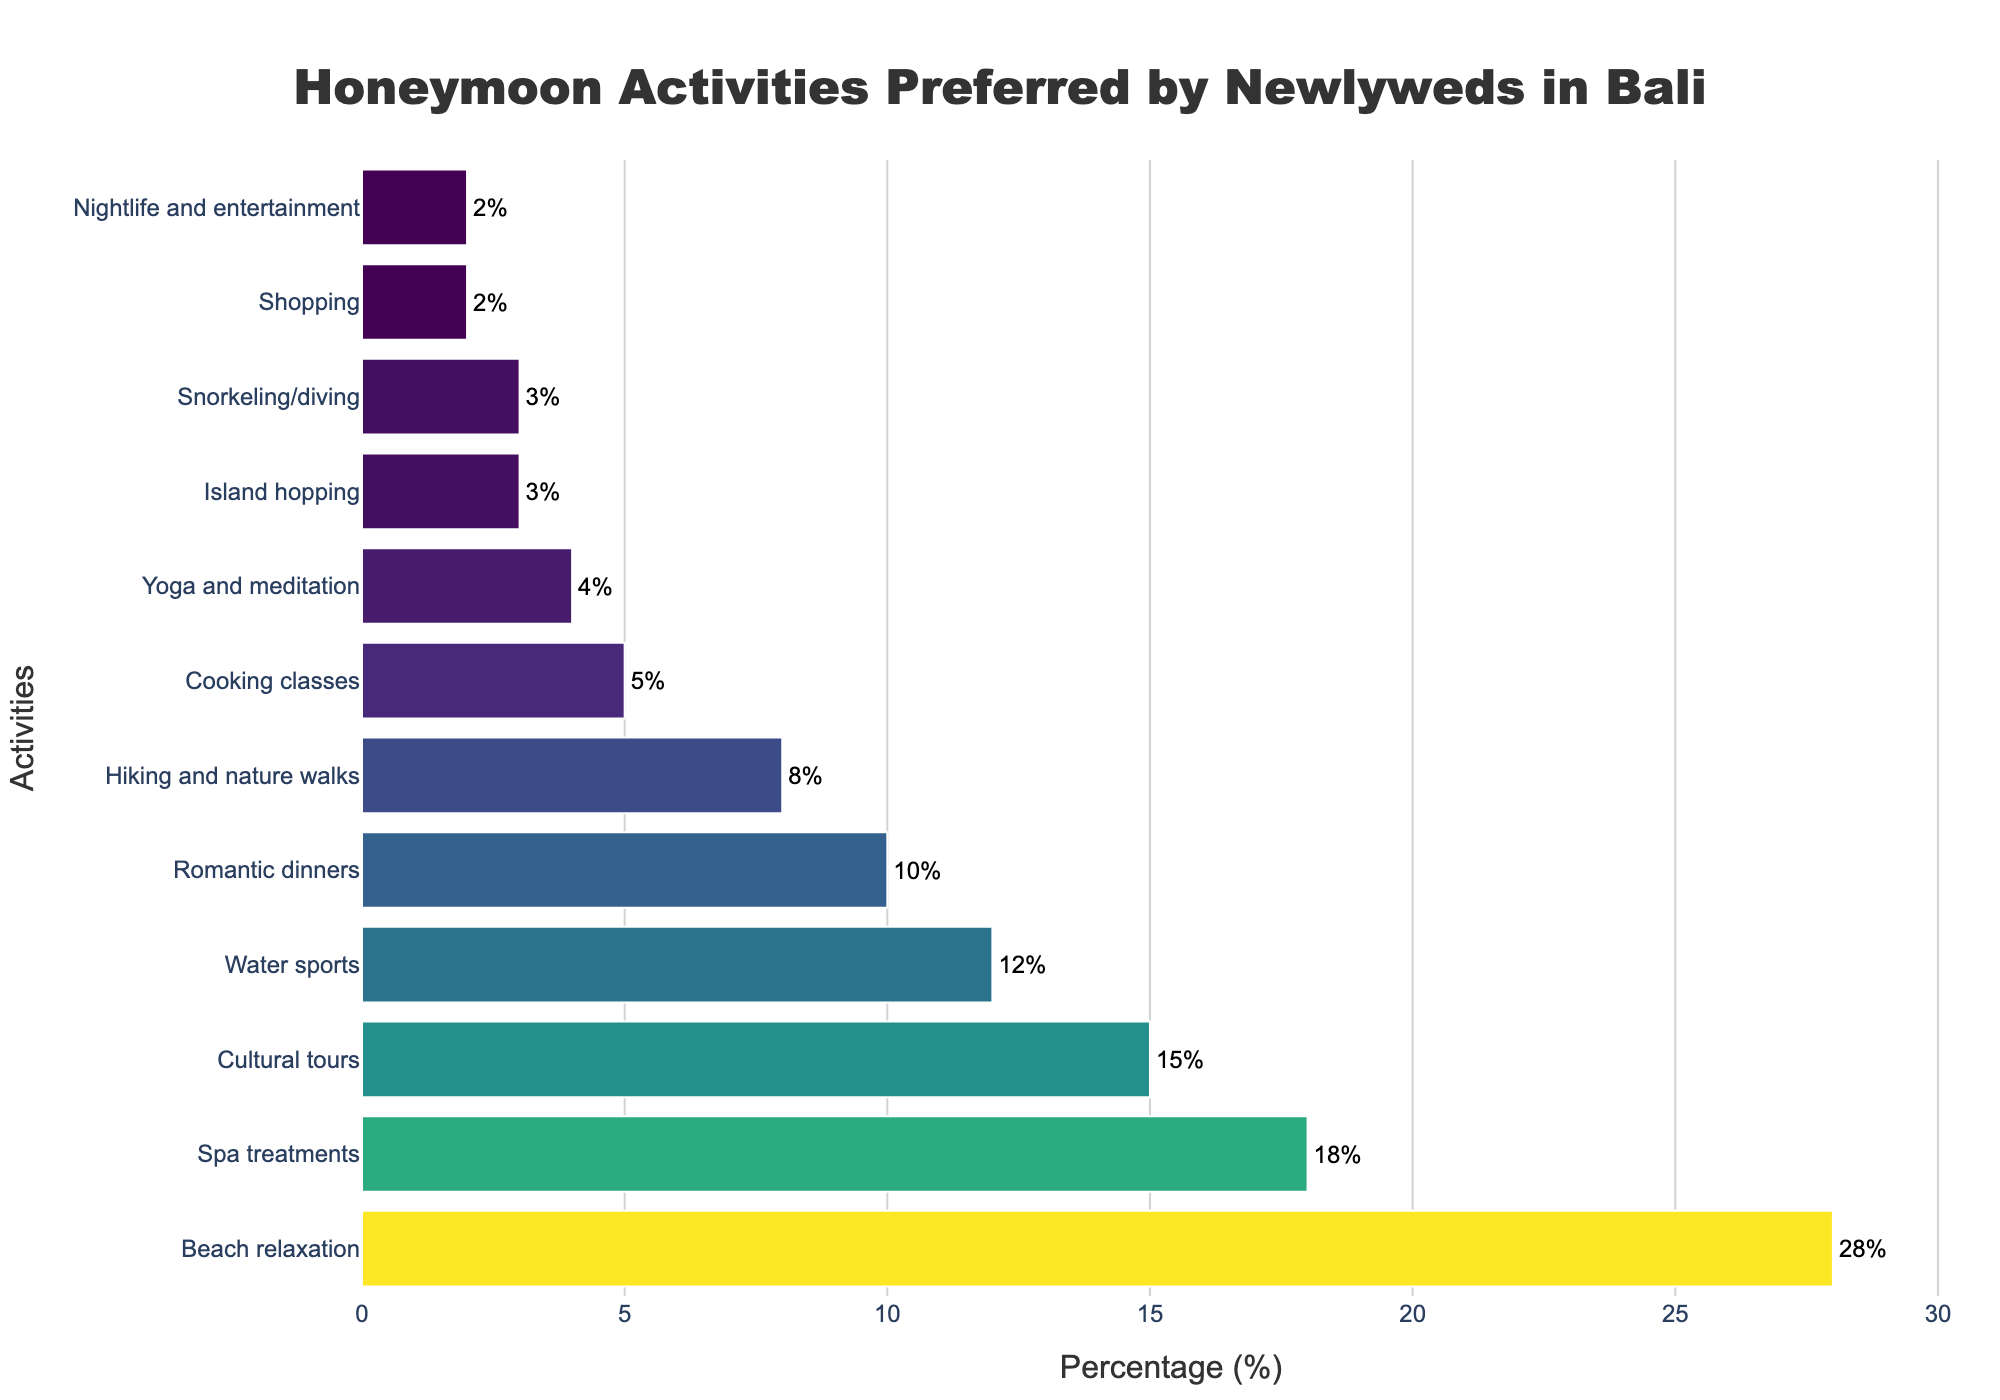What is the most preferred honeymoon activity by newlyweds in Bali? The figure shows various activities along with their respective percentages. The activity with the highest percentage is the most preferred.
Answer: Beach relaxation Which two honeymoon activities have the smallest percentage of preference? The figure lists activities by their percentage in descending order. The two activities with the smallest percentages are the ones at the bottom of the list.
Answer: Shopping, Nightlife and entertainment What is the difference in preference percentage between Spa treatments and Cultural tours? The figure shows Spa treatments have a percentage of 18% and Cultural tours have 15%. Subtracting these values gives the difference.
Answer: 3% What is the average preference percentage of Beach relaxation, Spa treatments, and Cultural tours? Sum the percentages of Beach relaxation (28%), Spa treatments (18%), and Cultural tours (15%) and then divide by three to get the average.
Answer: 20.33% Which activity is preferred twice as much as Yoga and meditation? Yoga and meditation have a percentage of 4%. Doubling this gives 8%, which matches the percentage for Hiking and nature walks.
Answer: Hiking and nature walks How many activities have a preference percentage of 10% or higher? Identify all activities with 10% or higher from the list. These activities are Beach relaxation (28%), Spa treatments (18%), Cultural tours (15%), Water sports (12%), and Romantic dinners (10%). Count these activities.
Answer: 5 Is the preference for Romantic dinners higher or lower than Water sports? The figure shows Romantic dinners at 10% and Water sports at 12%. Therefore, Romantic dinners have a lower percentage of preference.
Answer: Lower By how much does the preference for Cultural tours exceed Shopping? Cultural tours have 15% while Shopping has 2%. Subtract Shopping's percentage from Cultural tours' percentage to find the excess amount.
Answer: 13% What is the combined percentage of preference for Cooking classes and Yoga and meditation? Add the percentages for Cooking classes (5%) and Yoga and meditation (4%) to get the combined percentage.
Answer: 9% Which activity's preference percentage is closest to 5%? Review the percentages in the figure and identify the one closest to 5%. In this case, Cooking classes have exactly 5%.
Answer: Cooking classes 